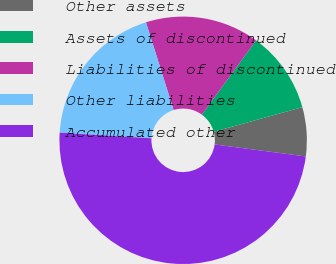Convert chart. <chart><loc_0><loc_0><loc_500><loc_500><pie_chart><fcel>Other assets<fcel>Assets of discontinued<fcel>Liabilities of discontinued<fcel>Other liabilities<fcel>Accumulated other<nl><fcel>6.4%<fcel>10.65%<fcel>14.9%<fcel>19.15%<fcel>48.91%<nl></chart> 